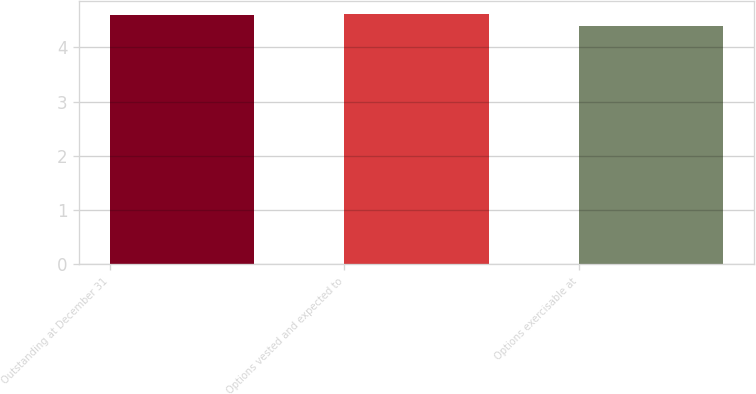<chart> <loc_0><loc_0><loc_500><loc_500><bar_chart><fcel>Outstanding at December 31<fcel>Options vested and expected to<fcel>Options exercisable at<nl><fcel>4.6<fcel>4.62<fcel>4.4<nl></chart> 